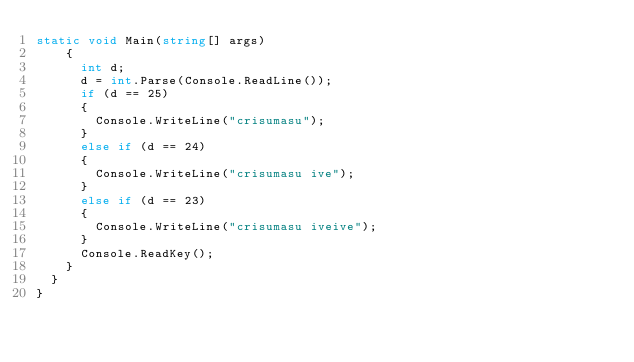<code> <loc_0><loc_0><loc_500><loc_500><_C#_>static void Main(string[] args)
		{
			int d;
			d = int.Parse(Console.ReadLine());
			if (d == 25)
			{
				Console.WriteLine("crisumasu");
			}
			else if (d == 24)
			{
				Console.WriteLine("crisumasu ive");
			}
			else if (d == 23)
			{
				Console.WriteLine("crisumasu iveive");
			}
			Console.ReadKey();
		}
	}
}
</code> 